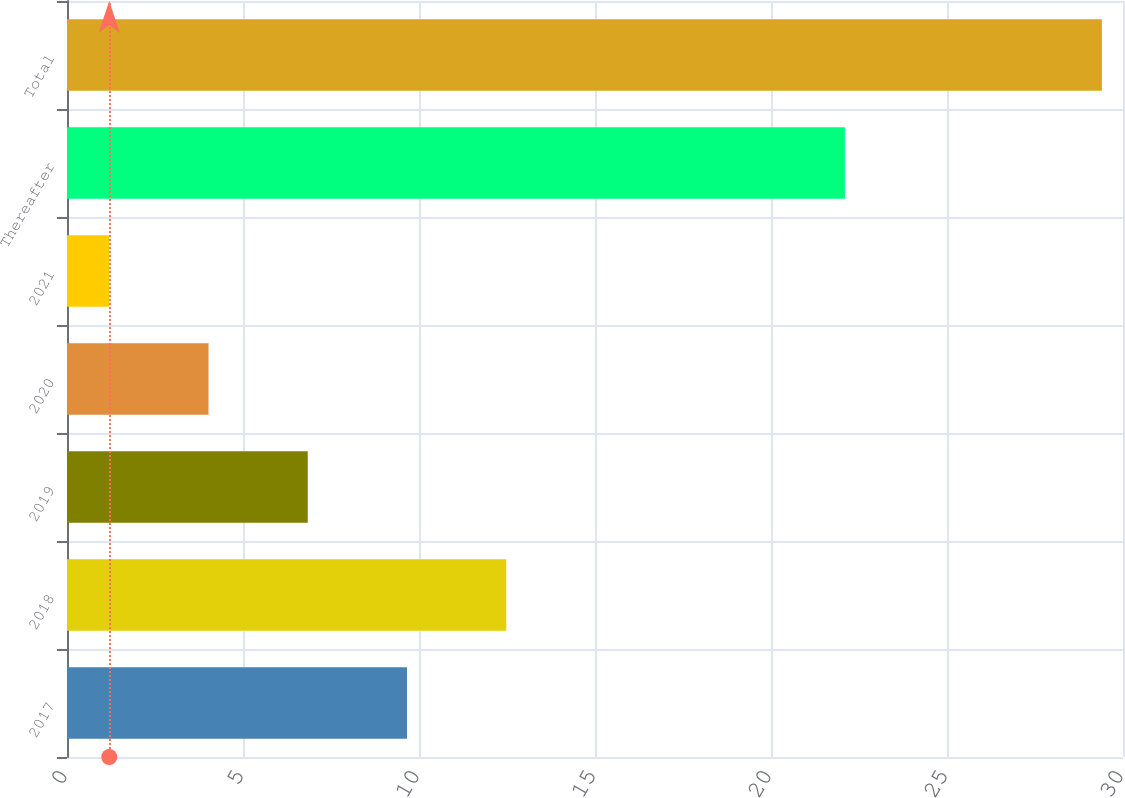<chart> <loc_0><loc_0><loc_500><loc_500><bar_chart><fcel>2017<fcel>2018<fcel>2019<fcel>2020<fcel>2021<fcel>Thereafter<fcel>Total<nl><fcel>9.66<fcel>12.48<fcel>6.84<fcel>4.02<fcel>1.2<fcel>22.1<fcel>29.4<nl></chart> 